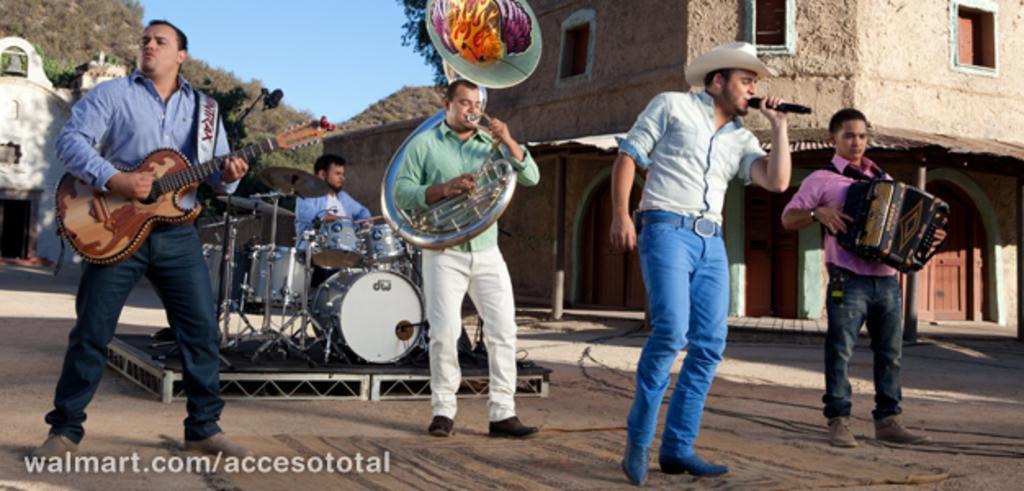Please provide a concise description of this image. In this image I can see group of people. Among them some people are playing musical instrument and one person is holding the mic. In the background there is a building,mountains and the sky. 